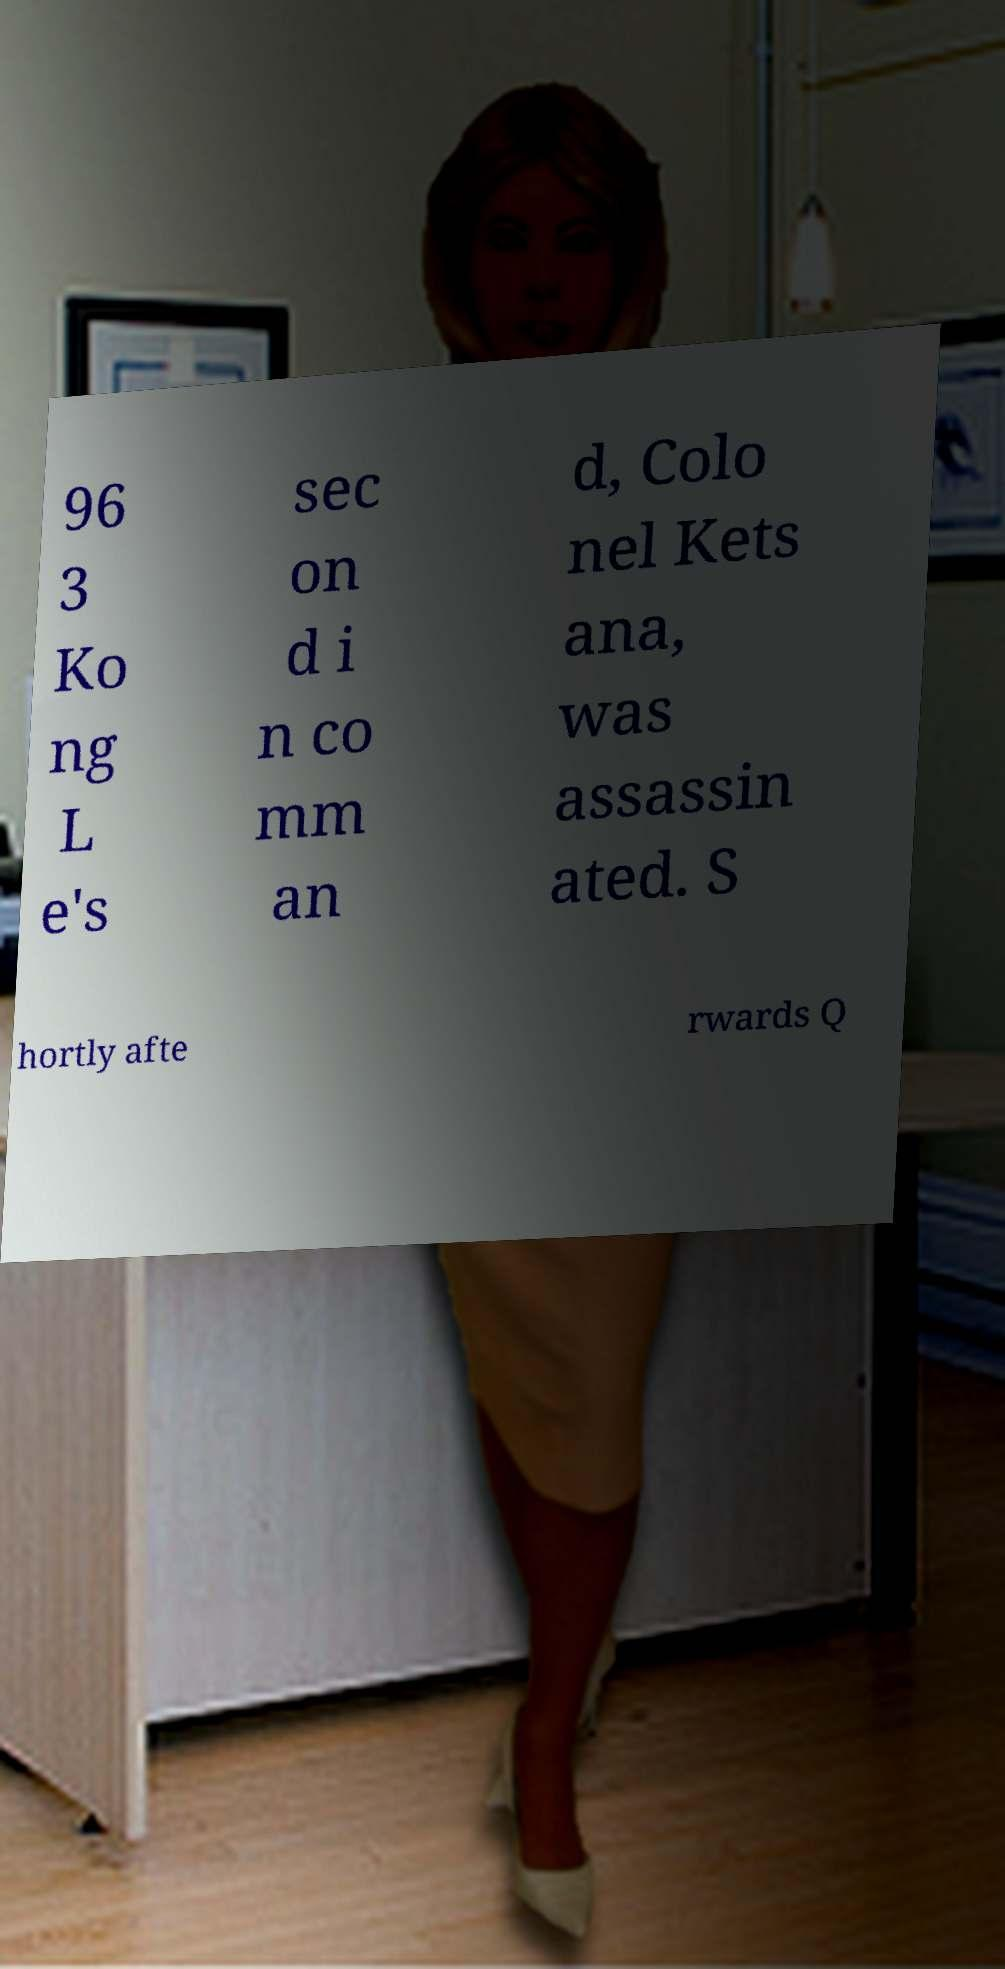Can you read and provide the text displayed in the image?This photo seems to have some interesting text. Can you extract and type it out for me? 96 3 Ko ng L e's sec on d i n co mm an d, Colo nel Kets ana, was assassin ated. S hortly afte rwards Q 